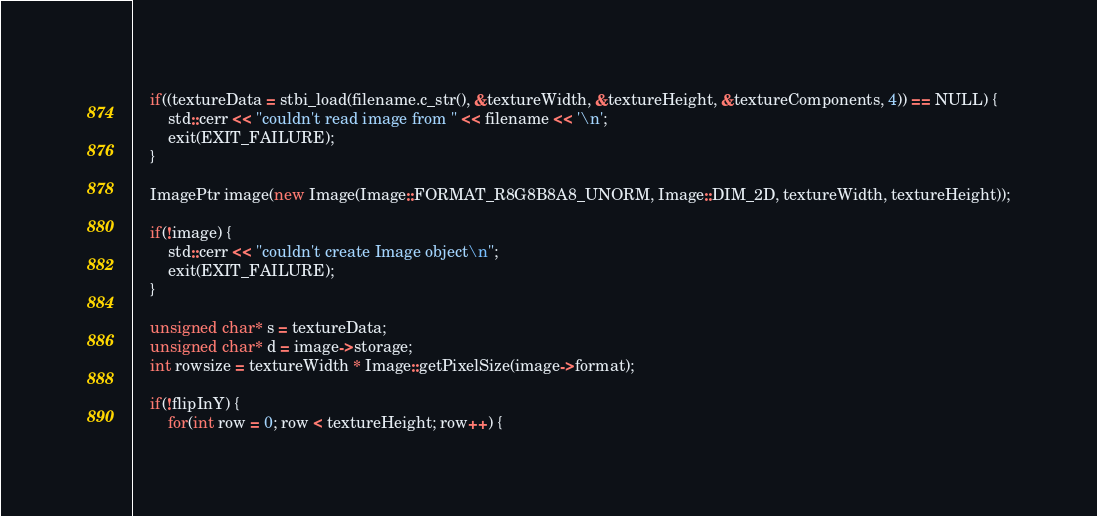<code> <loc_0><loc_0><loc_500><loc_500><_C++_>
    if((textureData = stbi_load(filename.c_str(), &textureWidth, &textureHeight, &textureComponents, 4)) == NULL) {
        std::cerr << "couldn't read image from " << filename << '\n';
        exit(EXIT_FAILURE);
    }

    ImagePtr image(new Image(Image::FORMAT_R8G8B8A8_UNORM, Image::DIM_2D, textureWidth, textureHeight));

    if(!image) {
        std::cerr << "couldn't create Image object\n";
        exit(EXIT_FAILURE);
    }

    unsigned char* s = textureData;
    unsigned char* d = image->storage;
    int rowsize = textureWidth * Image::getPixelSize(image->format);

    if(!flipInY) {
        for(int row = 0; row < textureHeight; row++) {</code> 